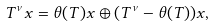Convert formula to latex. <formula><loc_0><loc_0><loc_500><loc_500>T ^ { \nu } x = \theta ( T ) x \oplus ( T ^ { \nu } - \theta ( T ) ) x ,</formula> 